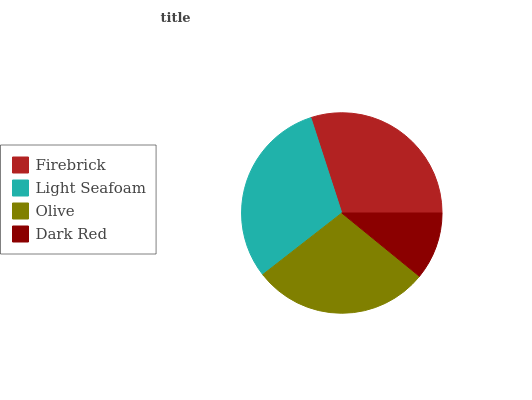Is Dark Red the minimum?
Answer yes or no. Yes. Is Light Seafoam the maximum?
Answer yes or no. Yes. Is Olive the minimum?
Answer yes or no. No. Is Olive the maximum?
Answer yes or no. No. Is Light Seafoam greater than Olive?
Answer yes or no. Yes. Is Olive less than Light Seafoam?
Answer yes or no. Yes. Is Olive greater than Light Seafoam?
Answer yes or no. No. Is Light Seafoam less than Olive?
Answer yes or no. No. Is Firebrick the high median?
Answer yes or no. Yes. Is Olive the low median?
Answer yes or no. Yes. Is Light Seafoam the high median?
Answer yes or no. No. Is Dark Red the low median?
Answer yes or no. No. 